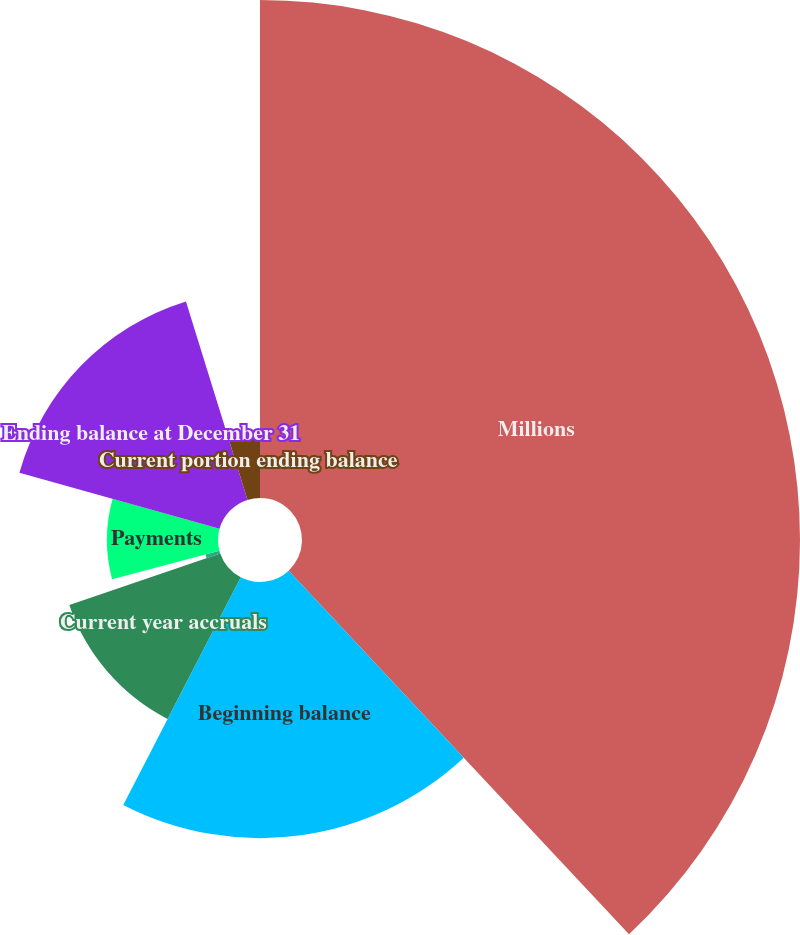Convert chart to OTSL. <chart><loc_0><loc_0><loc_500><loc_500><pie_chart><fcel>Millions<fcel>Beginning balance<fcel>Current year accruals<fcel>Changes in estimates for prior<fcel>Payments<fcel>Ending balance at December 31<fcel>Current portion ending balance<nl><fcel>38.03%<fcel>19.56%<fcel>12.18%<fcel>1.1%<fcel>8.48%<fcel>15.87%<fcel>4.79%<nl></chart> 